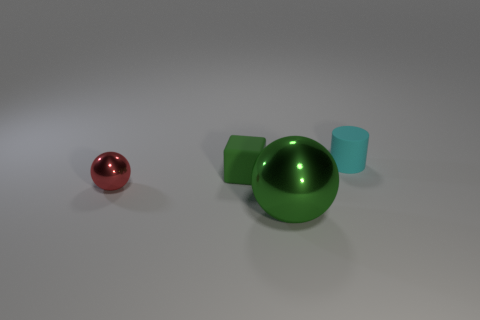Subtract all red balls. How many balls are left? 1 Add 4 cyan objects. How many objects exist? 8 Subtract all cyan things. Subtract all tiny balls. How many objects are left? 2 Add 1 red spheres. How many red spheres are left? 2 Add 2 large brown metallic things. How many large brown metallic things exist? 2 Subtract 1 cyan cylinders. How many objects are left? 3 Subtract all cylinders. How many objects are left? 3 